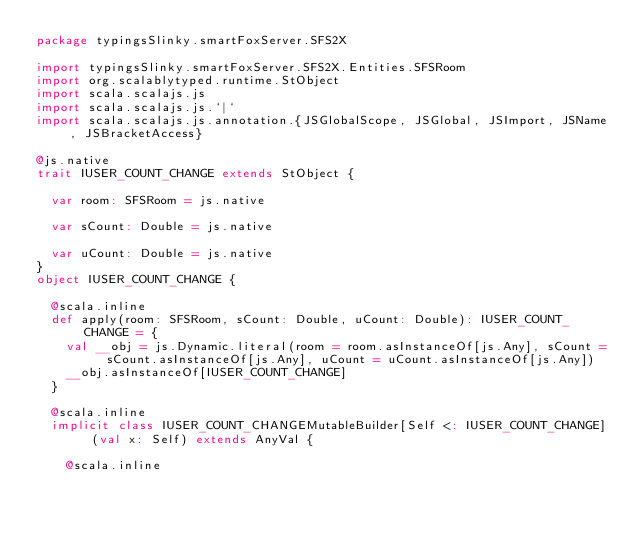Convert code to text. <code><loc_0><loc_0><loc_500><loc_500><_Scala_>package typingsSlinky.smartFoxServer.SFS2X

import typingsSlinky.smartFoxServer.SFS2X.Entities.SFSRoom
import org.scalablytyped.runtime.StObject
import scala.scalajs.js
import scala.scalajs.js.`|`
import scala.scalajs.js.annotation.{JSGlobalScope, JSGlobal, JSImport, JSName, JSBracketAccess}

@js.native
trait IUSER_COUNT_CHANGE extends StObject {
  
  var room: SFSRoom = js.native
  
  var sCount: Double = js.native
  
  var uCount: Double = js.native
}
object IUSER_COUNT_CHANGE {
  
  @scala.inline
  def apply(room: SFSRoom, sCount: Double, uCount: Double): IUSER_COUNT_CHANGE = {
    val __obj = js.Dynamic.literal(room = room.asInstanceOf[js.Any], sCount = sCount.asInstanceOf[js.Any], uCount = uCount.asInstanceOf[js.Any])
    __obj.asInstanceOf[IUSER_COUNT_CHANGE]
  }
  
  @scala.inline
  implicit class IUSER_COUNT_CHANGEMutableBuilder[Self <: IUSER_COUNT_CHANGE] (val x: Self) extends AnyVal {
    
    @scala.inline</code> 